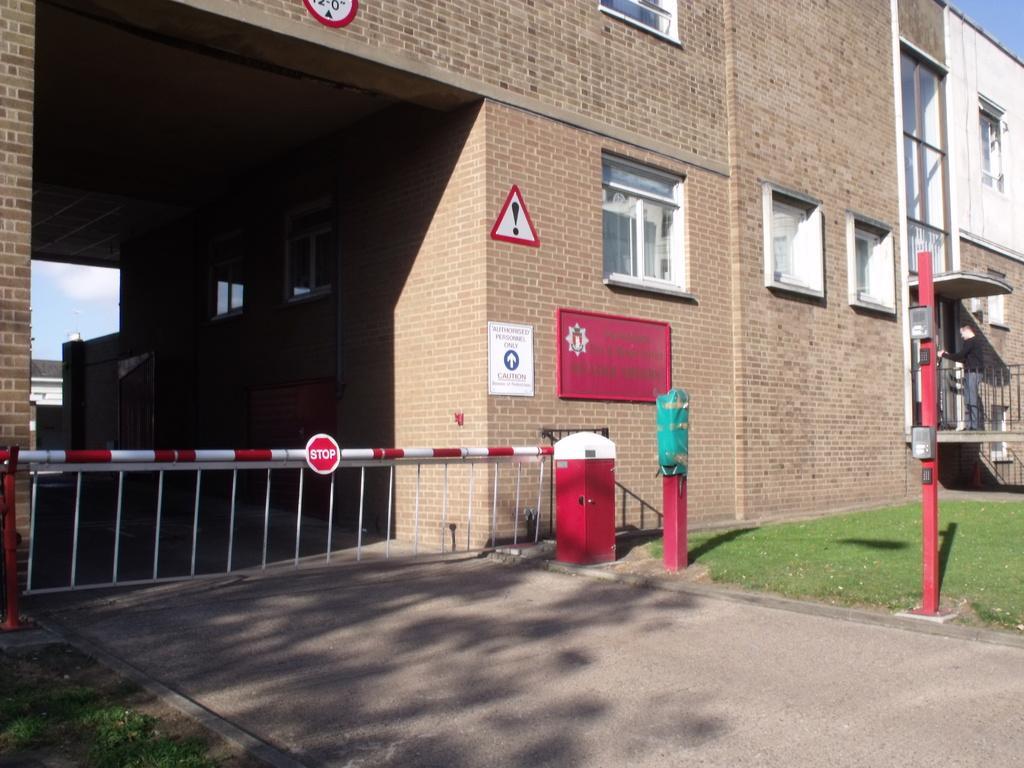Please provide a concise description of this image. At the bottom there is a road. On both sides of the road I can see the grass. Here I can see a building along with windows. There are few boards attached to the wall. On the left side there is a railing. 